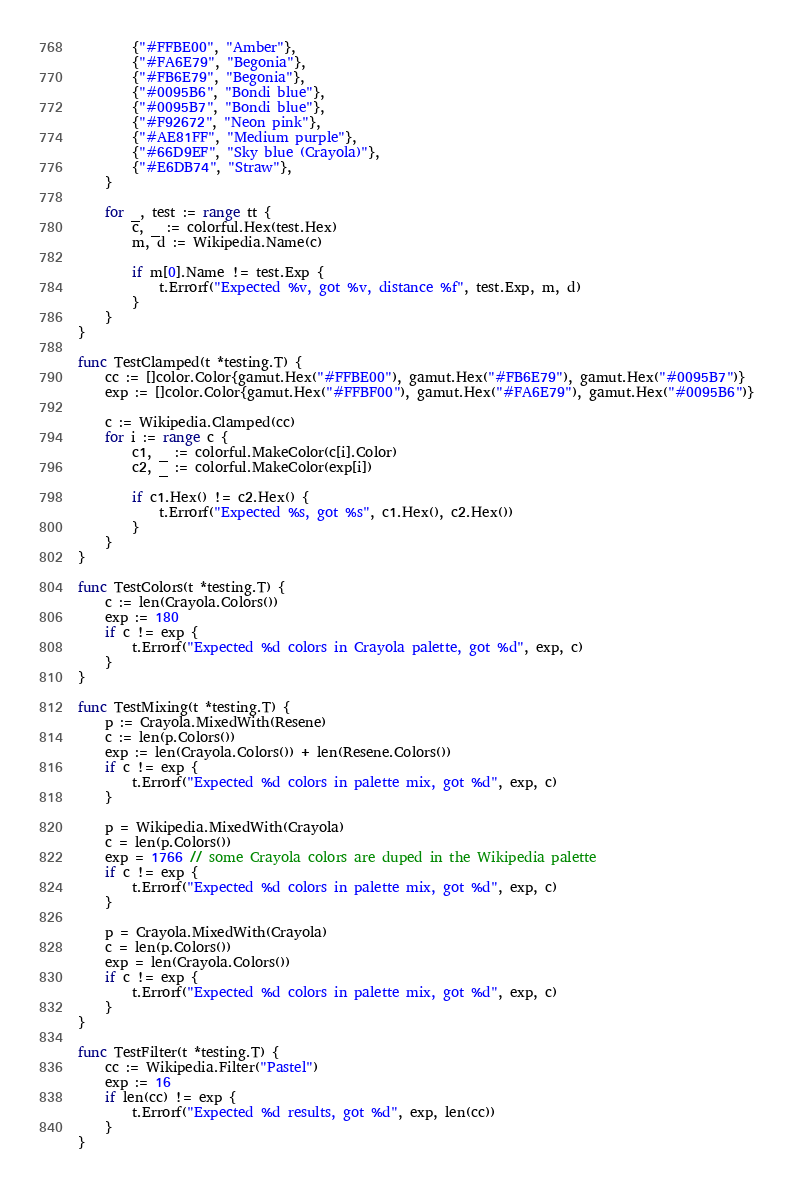Convert code to text. <code><loc_0><loc_0><loc_500><loc_500><_Go_>		{"#FFBE00", "Amber"},
		{"#FA6E79", "Begonia"},
		{"#FB6E79", "Begonia"},
		{"#0095B6", "Bondi blue"},
		{"#0095B7", "Bondi blue"},
		{"#F92672", "Neon pink"},
		{"#AE81FF", "Medium purple"},
		{"#66D9EF", "Sky blue (Crayola)"},
		{"#E6DB74", "Straw"},
	}

	for _, test := range tt {
		c, _ := colorful.Hex(test.Hex)
		m, d := Wikipedia.Name(c)

		if m[0].Name != test.Exp {
			t.Errorf("Expected %v, got %v, distance %f", test.Exp, m, d)
		}
	}
}

func TestClamped(t *testing.T) {
	cc := []color.Color{gamut.Hex("#FFBE00"), gamut.Hex("#FB6E79"), gamut.Hex("#0095B7")}
	exp := []color.Color{gamut.Hex("#FFBF00"), gamut.Hex("#FA6E79"), gamut.Hex("#0095B6")}

	c := Wikipedia.Clamped(cc)
	for i := range c {
		c1, _ := colorful.MakeColor(c[i].Color)
		c2, _ := colorful.MakeColor(exp[i])

		if c1.Hex() != c2.Hex() {
			t.Errorf("Expected %s, got %s", c1.Hex(), c2.Hex())
		}
	}
}

func TestColors(t *testing.T) {
	c := len(Crayola.Colors())
	exp := 180
	if c != exp {
		t.Errorf("Expected %d colors in Crayola palette, got %d", exp, c)
	}
}

func TestMixing(t *testing.T) {
	p := Crayola.MixedWith(Resene)
	c := len(p.Colors())
	exp := len(Crayola.Colors()) + len(Resene.Colors())
	if c != exp {
		t.Errorf("Expected %d colors in palette mix, got %d", exp, c)
	}

	p = Wikipedia.MixedWith(Crayola)
	c = len(p.Colors())
	exp = 1766 // some Crayola colors are duped in the Wikipedia palette
	if c != exp {
		t.Errorf("Expected %d colors in palette mix, got %d", exp, c)
	}

	p = Crayola.MixedWith(Crayola)
	c = len(p.Colors())
	exp = len(Crayola.Colors())
	if c != exp {
		t.Errorf("Expected %d colors in palette mix, got %d", exp, c)
	}
}

func TestFilter(t *testing.T) {
	cc := Wikipedia.Filter("Pastel")
	exp := 16
	if len(cc) != exp {
		t.Errorf("Expected %d results, got %d", exp, len(cc))
	}
}
</code> 